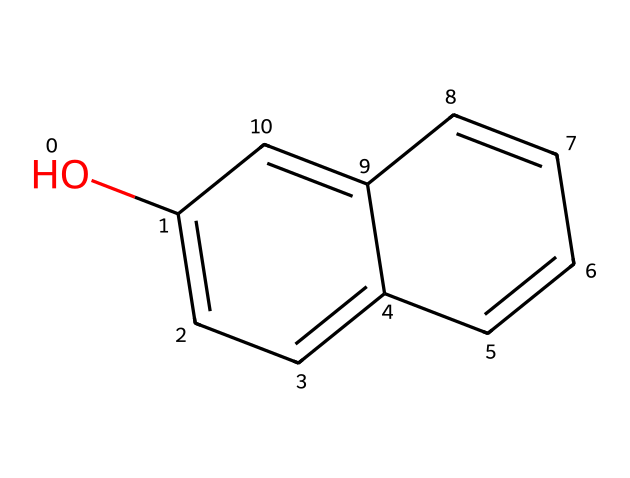What is the molecular formula of creosote represented in the SMILES? By analyzing the SMILES provided, the structure can be interpreted to reveal it contains six carbon atoms (c), and six hydrogen atoms (H) attached to it, resulting in the molecular formula C6H6.
Answer: C6H6 How many rings are present in the chemical structure of creosote? The SMILES notation indicates a fused ring system; counting the distinct rings shows there are two rings.
Answer: 2 What functional group is present in creosote? The "O" and "c" in the SMILES suggest the presence of a hydroxyl (-OH) group, characteristic of phenolic compounds.
Answer: hydroxyl Is this chemical likely to be soluble in water? The presence of the hydroxyl group suggests moderate solubility in water, but due to the non-polar ring structure, overall it is not highly soluble.
Answer: no What property of creosote causes it to be used as a wood preservative? The presence of phenolic compounds contributes to antimicrobial properties, making it effective against decay and pests.
Answer: antimicrobial What type of chemical is creosote classified as? Based on the hydroxyl group and carbon ring system observed in the structure, creosote is classified as a phenol.
Answer: phenol 